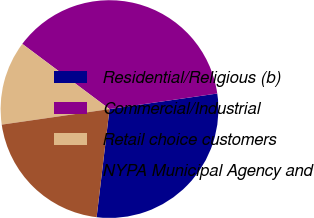Convert chart. <chart><loc_0><loc_0><loc_500><loc_500><pie_chart><fcel>Residential/Religious (b)<fcel>Commercial/Industrial<fcel>Retail choice customers<fcel>NYPA Municipal Agency and<nl><fcel>29.17%<fcel>37.5%<fcel>12.5%<fcel>20.83%<nl></chart> 